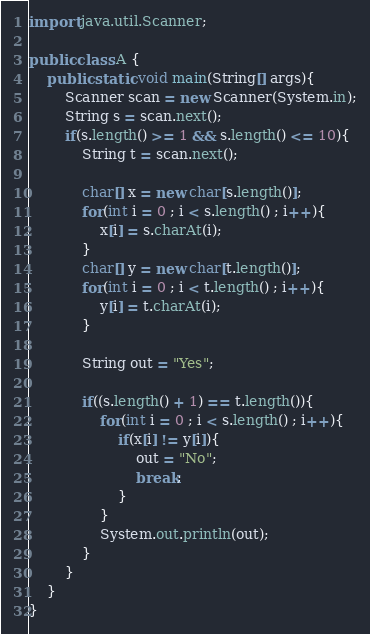Convert code to text. <code><loc_0><loc_0><loc_500><loc_500><_Java_>import java.util.Scanner;

public class A {
    public static void main(String[] args){
        Scanner scan = new Scanner(System.in);
        String s = scan.next();
        if(s.length() >= 1 && s.length() <= 10){
            String t = scan.next();

            char[] x = new char[s.length()];
            for(int i = 0 ; i < s.length() ; i++){
                x[i] = s.charAt(i);
            }
            char[] y = new char[t.length()];
            for(int i = 0 ; i < t.length() ; i++){
                y[i] = t.charAt(i);
            }

            String out = "Yes";

            if((s.length() + 1) == t.length()){
                for(int i = 0 ; i < s.length() ; i++){
                    if(x[i] != y[i]){
                        out = "No";
                        break;
                    }
                }
                System.out.println(out);
            }
        }
    }
}</code> 